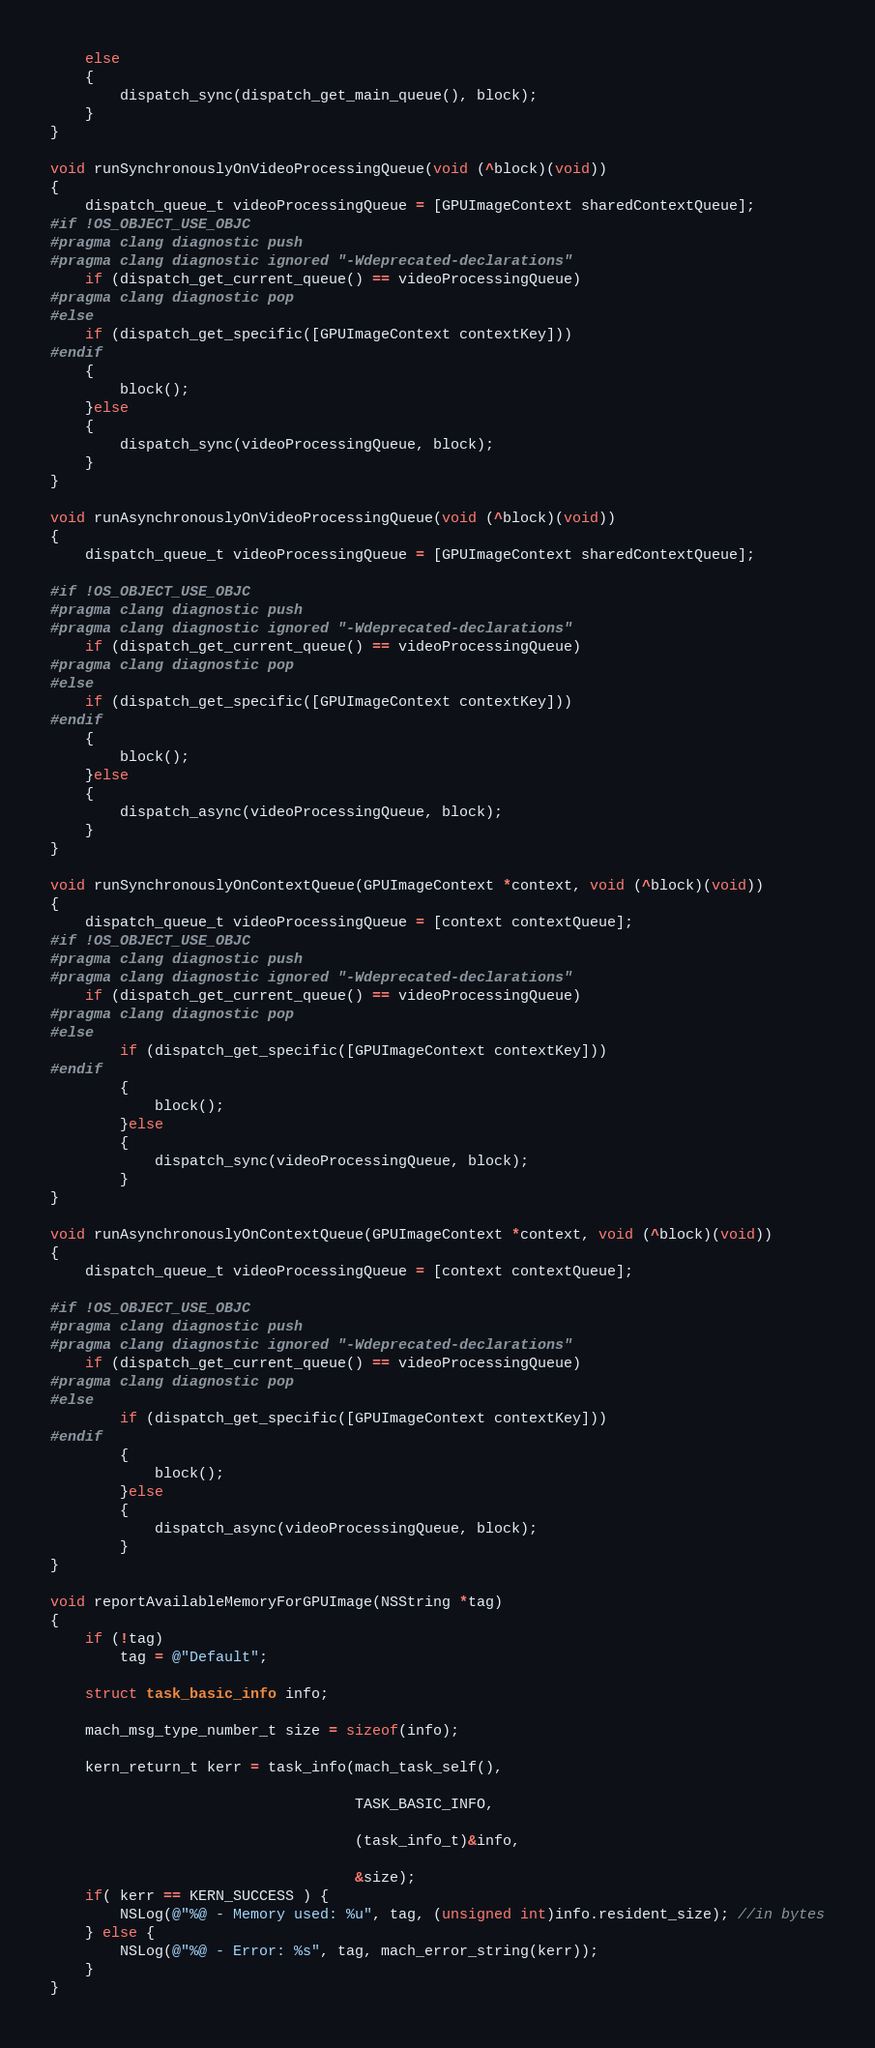<code> <loc_0><loc_0><loc_500><loc_500><_ObjectiveC_>	else
	{
		dispatch_sync(dispatch_get_main_queue(), block);
	}
}

void runSynchronouslyOnVideoProcessingQueue(void (^block)(void))
{
    dispatch_queue_t videoProcessingQueue = [GPUImageContext sharedContextQueue];
#if !OS_OBJECT_USE_OBJC
#pragma clang diagnostic push
#pragma clang diagnostic ignored "-Wdeprecated-declarations"
    if (dispatch_get_current_queue() == videoProcessingQueue)
#pragma clang diagnostic pop
#else
	if (dispatch_get_specific([GPUImageContext contextKey]))
#endif
	{
		block();
	}else
	{
		dispatch_sync(videoProcessingQueue, block);
	}
}

void runAsynchronouslyOnVideoProcessingQueue(void (^block)(void))
{
    dispatch_queue_t videoProcessingQueue = [GPUImageContext sharedContextQueue];
    
#if !OS_OBJECT_USE_OBJC
#pragma clang diagnostic push
#pragma clang diagnostic ignored "-Wdeprecated-declarations"
    if (dispatch_get_current_queue() == videoProcessingQueue)
#pragma clang diagnostic pop
#else
    if (dispatch_get_specific([GPUImageContext contextKey]))
#endif
	{
		block();
	}else
	{
		dispatch_async(videoProcessingQueue, block);
	}
}

void runSynchronouslyOnContextQueue(GPUImageContext *context, void (^block)(void))
{
    dispatch_queue_t videoProcessingQueue = [context contextQueue];
#if !OS_OBJECT_USE_OBJC
#pragma clang diagnostic push
#pragma clang diagnostic ignored "-Wdeprecated-declarations"
    if (dispatch_get_current_queue() == videoProcessingQueue)
#pragma clang diagnostic pop
#else
        if (dispatch_get_specific([GPUImageContext contextKey]))
#endif
        {
            block();
        }else
        {
            dispatch_sync(videoProcessingQueue, block);
        }
}

void runAsynchronouslyOnContextQueue(GPUImageContext *context, void (^block)(void))
{
    dispatch_queue_t videoProcessingQueue = [context contextQueue];
    
#if !OS_OBJECT_USE_OBJC
#pragma clang diagnostic push
#pragma clang diagnostic ignored "-Wdeprecated-declarations"
    if (dispatch_get_current_queue() == videoProcessingQueue)
#pragma clang diagnostic pop
#else
        if (dispatch_get_specific([GPUImageContext contextKey]))
#endif
        {
            block();
        }else
        {
            dispatch_async(videoProcessingQueue, block);
        }
}

void reportAvailableMemoryForGPUImage(NSString *tag) 
{    
    if (!tag)
        tag = @"Default";
    
    struct task_basic_info info;
    
    mach_msg_type_number_t size = sizeof(info);
    
    kern_return_t kerr = task_info(mach_task_self(),
                                   
                                   TASK_BASIC_INFO,
                                   
                                   (task_info_t)&info,
                                   
                                   &size);    
    if( kerr == KERN_SUCCESS ) {        
        NSLog(@"%@ - Memory used: %u", tag, (unsigned int)info.resident_size); //in bytes
    } else {        
        NSLog(@"%@ - Error: %s", tag, mach_error_string(kerr));        
    }    
}

</code> 